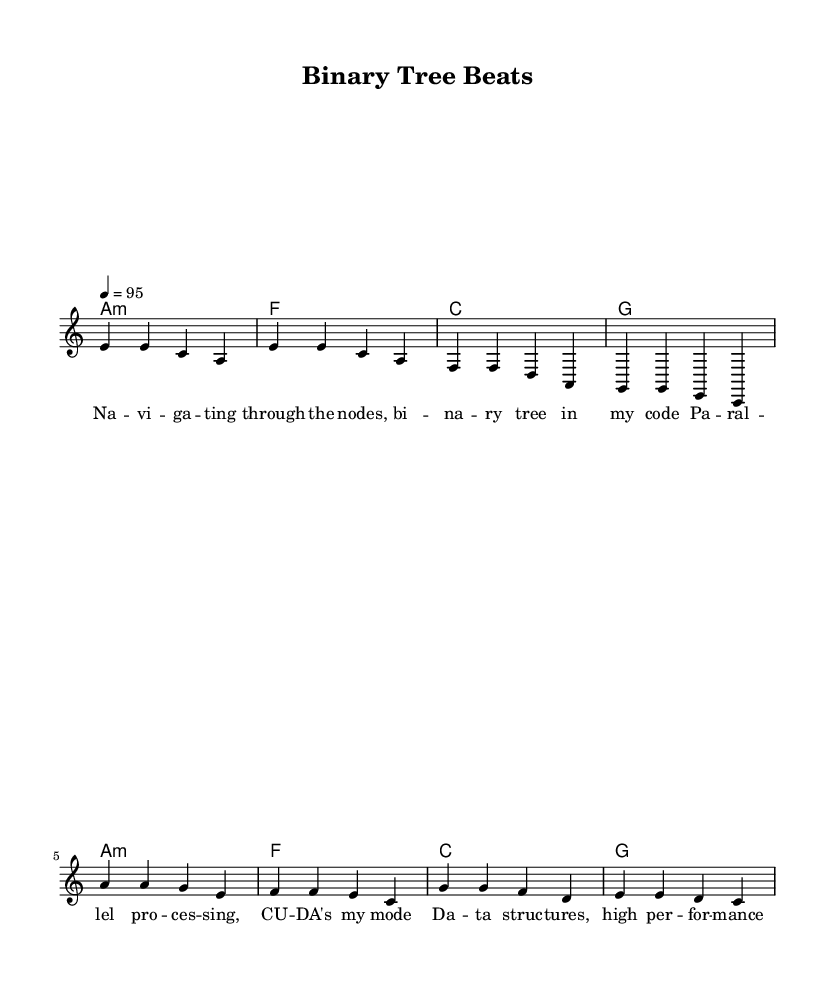What is the key signature of this music? The key signature is indicated by the first part of the score, which shows one flat. This corresponds to the key of A minor, which has no sharps or flats in the major scale context but is written with the flat for reference.
Answer: A minor What is the time signature of this music? The time signature appears at the beginning of the score right after the key signature. It is notated as 4/4, indicating four beats per measure with a quarter note receiving one beat.
Answer: 4/4 What is the tempo marking in this music? The tempo marking is found at the beginning of the score, indicated as "4 = 95", which denotes 95 beats per minute for quarter note beats.
Answer: 95 How many measures are there in the verse section? By counting the note groupings (measures) in the verse section, we find that there are four measures in total, as shown in the notation.
Answer: 4 In which part do the lyrics mention parallel processing? The lyrics specifically mention "pa -- ral -- lel pro -- ces -- sing" in the verse section, indicating the focus on parallel processing within the context of computing.
Answer: Verse What is the chord played in the chorus? The chorus part starts with the chord A minor, as seen in the chord mode notation at the beginning of the chorus section, followed by a sequence of chords.
Answer: A minor What is the primary theme of the lyrics in this music? The lyrics reflect themes of data structures and high-performance computing, emphasizing elements of parallel processing and GPU computing, indicative of a passion for computer science.
Answer: Data structures and high-performance computing 